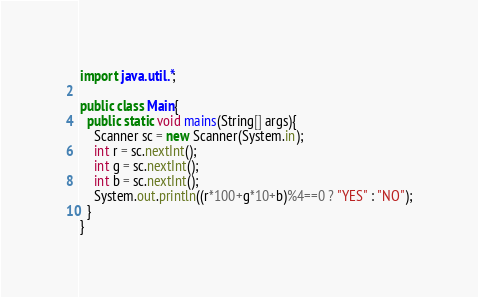Convert code to text. <code><loc_0><loc_0><loc_500><loc_500><_Java_>import java.util.*;

public class Main{
  public static void mains(String[] args){
    Scanner sc = new Scanner(System.in);
    int r = sc.nextInt();
    int g = sc.nextInt();
    int b = sc.nextInt();
    System.out.println((r*100+g*10+b)%4==0 ? "YES" : "NO");
  }
}
</code> 